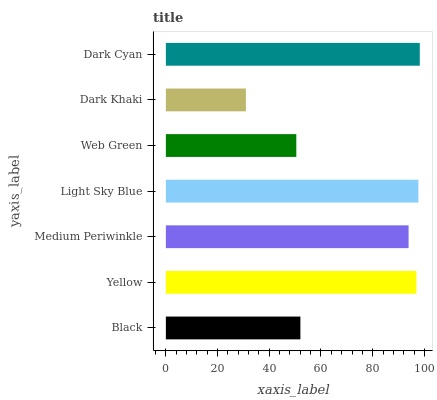Is Dark Khaki the minimum?
Answer yes or no. Yes. Is Dark Cyan the maximum?
Answer yes or no. Yes. Is Yellow the minimum?
Answer yes or no. No. Is Yellow the maximum?
Answer yes or no. No. Is Yellow greater than Black?
Answer yes or no. Yes. Is Black less than Yellow?
Answer yes or no. Yes. Is Black greater than Yellow?
Answer yes or no. No. Is Yellow less than Black?
Answer yes or no. No. Is Medium Periwinkle the high median?
Answer yes or no. Yes. Is Medium Periwinkle the low median?
Answer yes or no. Yes. Is Dark Cyan the high median?
Answer yes or no. No. Is Light Sky Blue the low median?
Answer yes or no. No. 